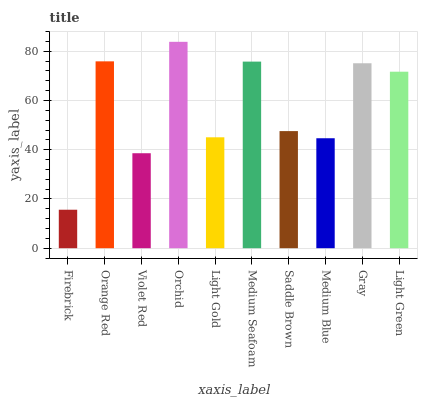Is Firebrick the minimum?
Answer yes or no. Yes. Is Orchid the maximum?
Answer yes or no. Yes. Is Orange Red the minimum?
Answer yes or no. No. Is Orange Red the maximum?
Answer yes or no. No. Is Orange Red greater than Firebrick?
Answer yes or no. Yes. Is Firebrick less than Orange Red?
Answer yes or no. Yes. Is Firebrick greater than Orange Red?
Answer yes or no. No. Is Orange Red less than Firebrick?
Answer yes or no. No. Is Light Green the high median?
Answer yes or no. Yes. Is Saddle Brown the low median?
Answer yes or no. Yes. Is Firebrick the high median?
Answer yes or no. No. Is Violet Red the low median?
Answer yes or no. No. 